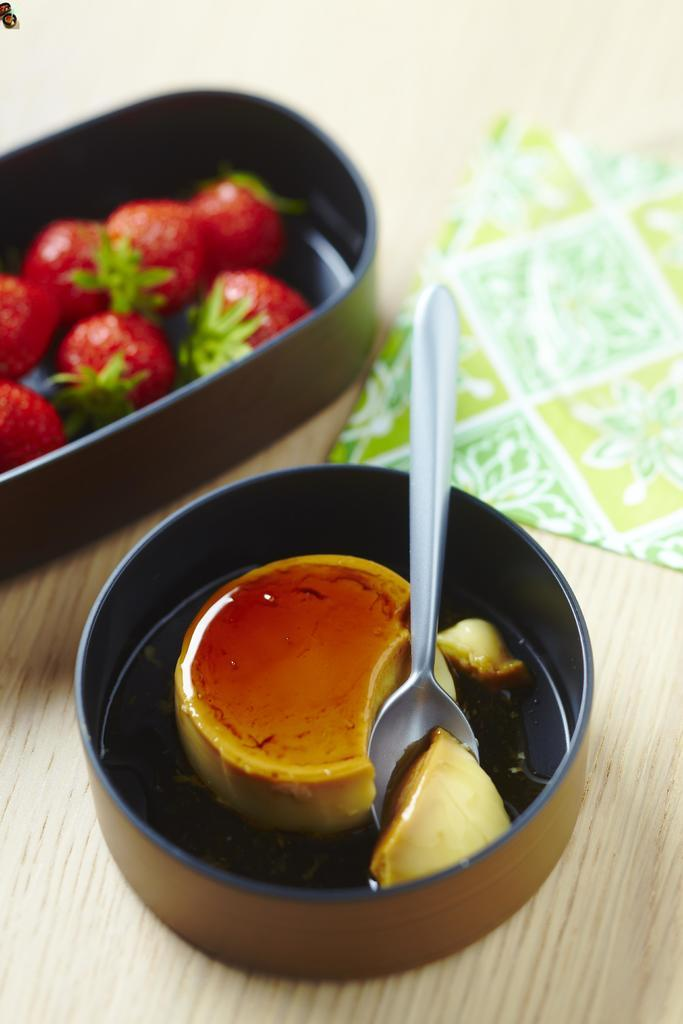What type of fruit is in the bowl in the image? There are strawberries in a bowl in the image. What is the other main item in the bowl in the image? There is ice cream in a bowl in the image. What utensil is present in the image? A spoon is present in the image. What might be used for cleaning or wiping in the image? A napkin is visible in the image. What type of surface are the objects placed on in the image? The objects are on a wooden table in the image. What type of lettuce is being served with the strawberries in the image? There is no lettuce present in the image; it features strawberries and ice cream in separate bowls. Can you see a robin perched on the wooden table in the image? There is no robin present in the image; it only shows a wooden table with bowls of strawberries and ice cream, a spoon, and a napkin. 